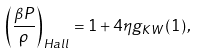Convert formula to latex. <formula><loc_0><loc_0><loc_500><loc_500>\left ( \frac { \beta P } { \rho } \right ) _ { H a l l } = 1 + 4 \eta g _ { K W } \left ( 1 \right ) ,</formula> 